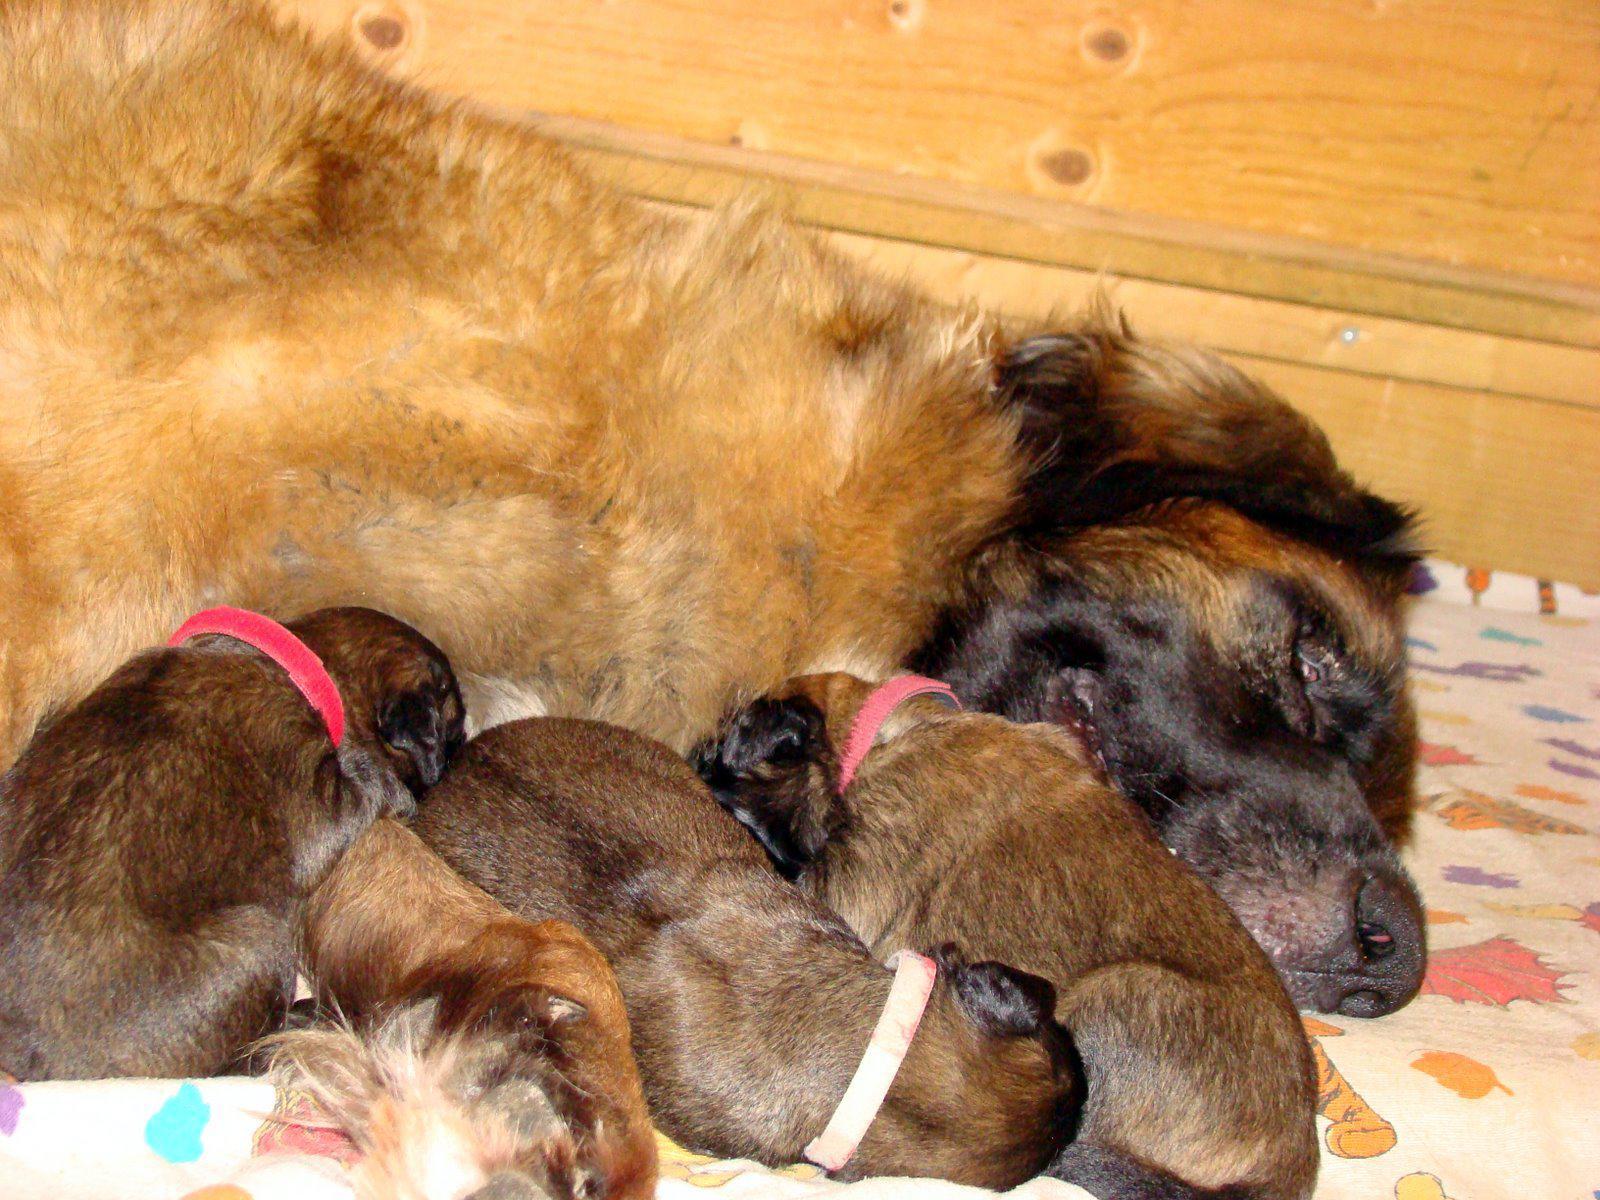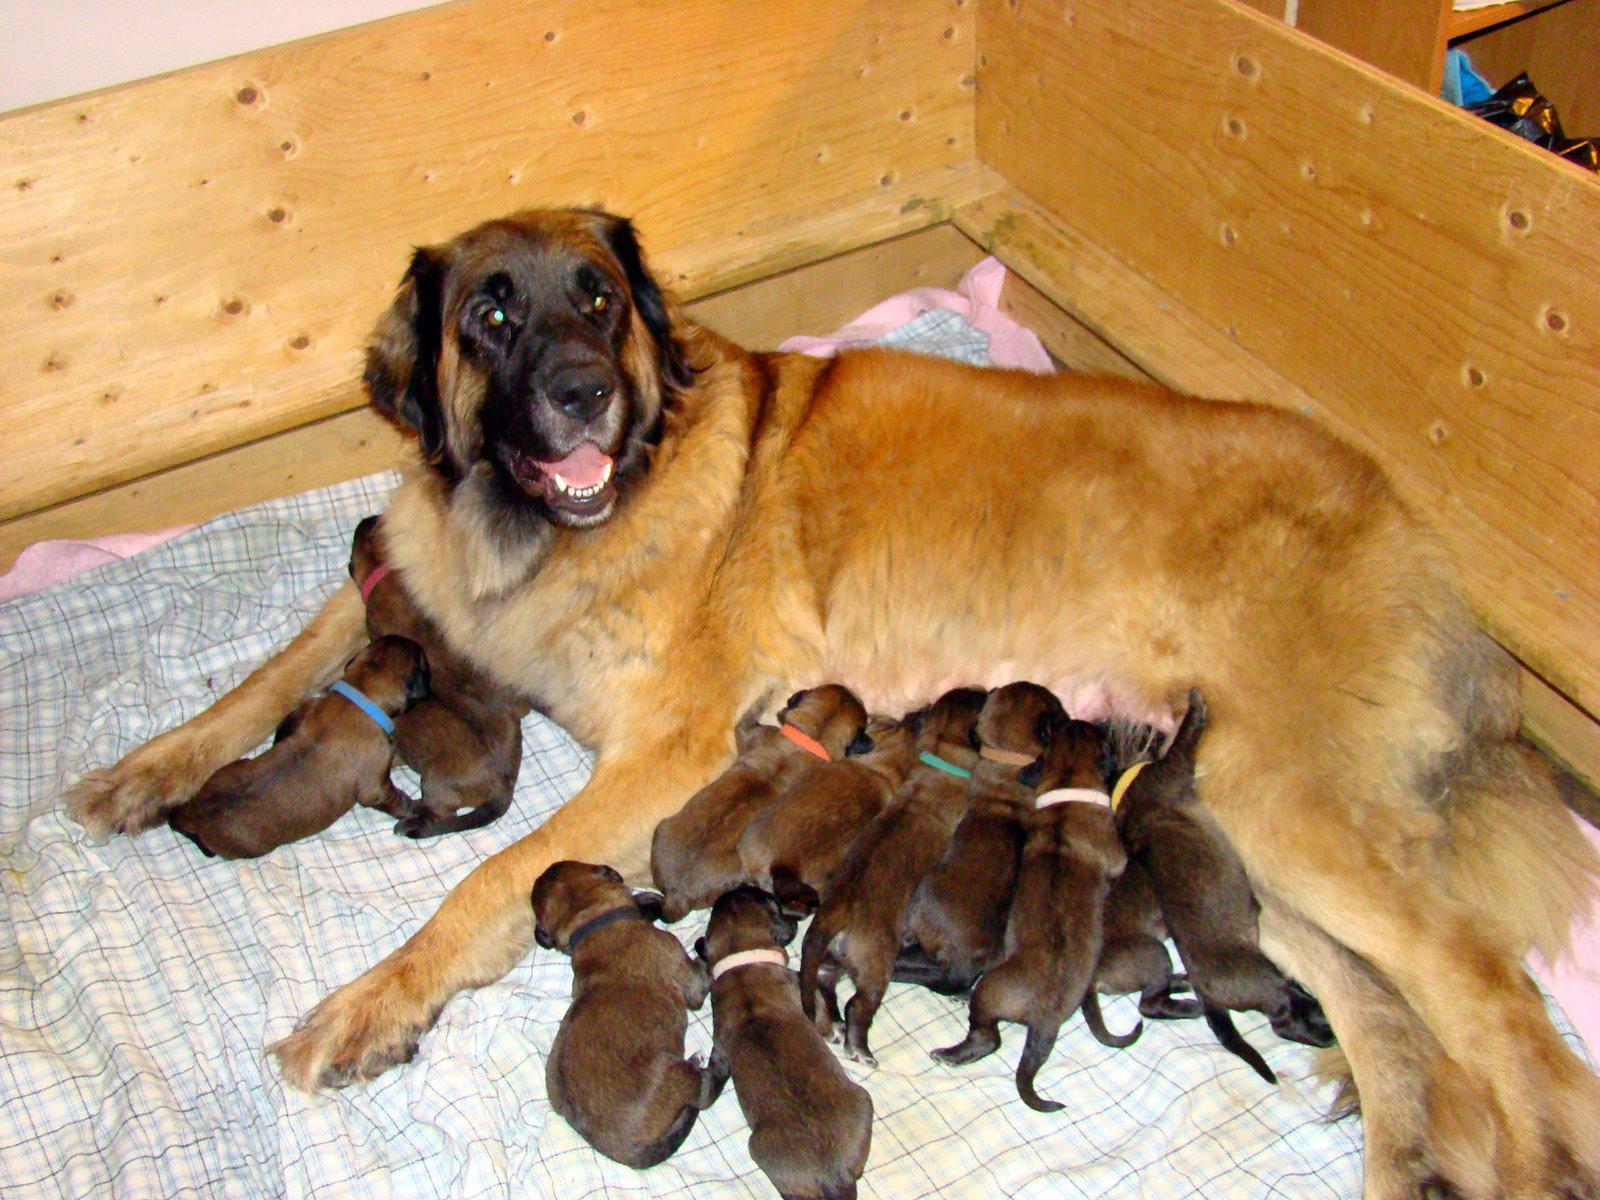The first image is the image on the left, the second image is the image on the right. Assess this claim about the two images: "Right image shows a mother dog with raised head and her pups, surrounded by a natural wood border.". Correct or not? Answer yes or no. Yes. The first image is the image on the left, the second image is the image on the right. Analyze the images presented: Is the assertion "The dog in the image on the right is nursing in an area surrounded by wooden planks." valid? Answer yes or no. Yes. 